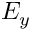Convert formula to latex. <formula><loc_0><loc_0><loc_500><loc_500>E _ { y }</formula> 